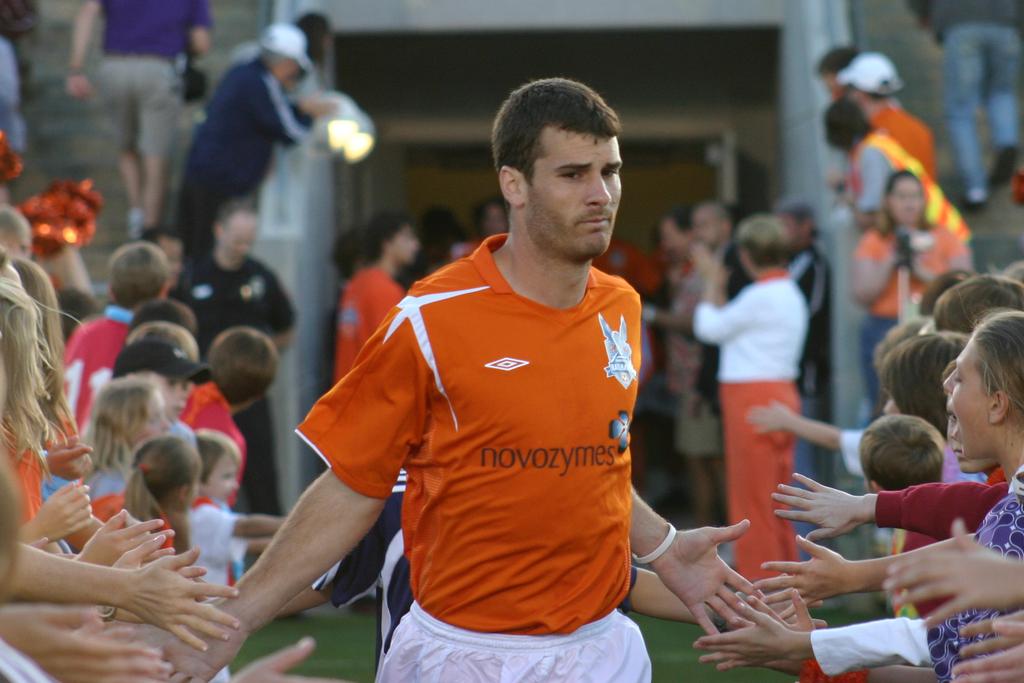What is the number on the kid's red shirt?
Your response must be concise. 11. 